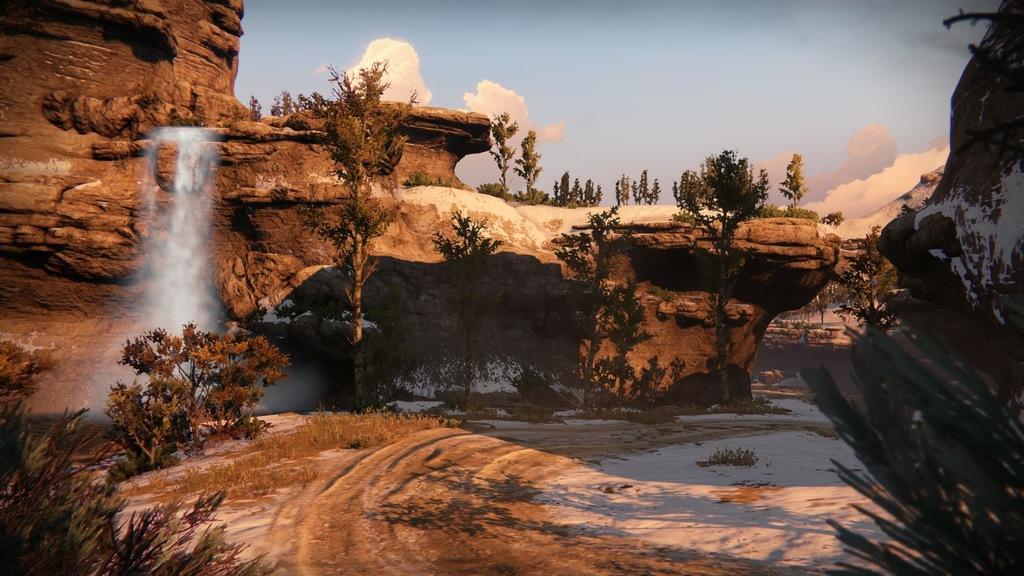How would you summarize this image in a sentence or two? This is an outside view. In this image, I can see many trees, rocks and snow on the ground. On the left side, I can see the waterfalls. At the top of the image I can see the sky and clouds. 